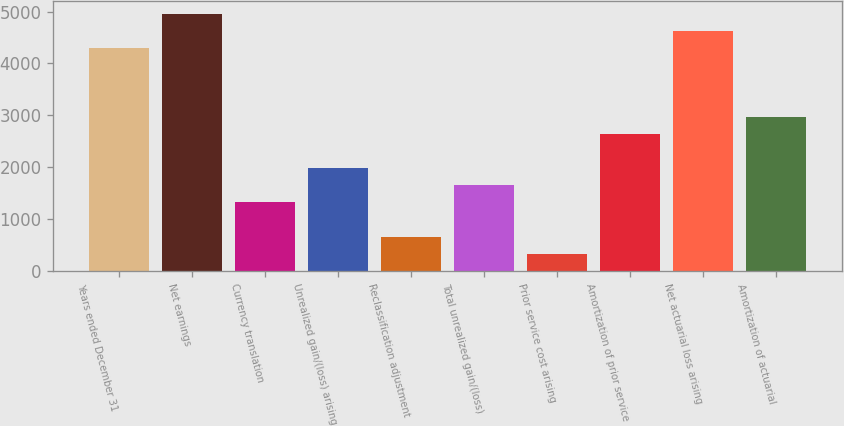Convert chart. <chart><loc_0><loc_0><loc_500><loc_500><bar_chart><fcel>Years ended December 31<fcel>Net earnings<fcel>Currency translation<fcel>Unrealized gain/(loss) arising<fcel>Reclassification adjustment<fcel>Total unrealized gain/(loss)<fcel>Prior service cost arising<fcel>Amortization of prior service<fcel>Net actuarial loss arising<fcel>Amortization of actuarial<nl><fcel>4298.8<fcel>4960<fcel>1323.4<fcel>1984.6<fcel>662.2<fcel>1654<fcel>331.6<fcel>2645.8<fcel>4629.4<fcel>2976.4<nl></chart> 